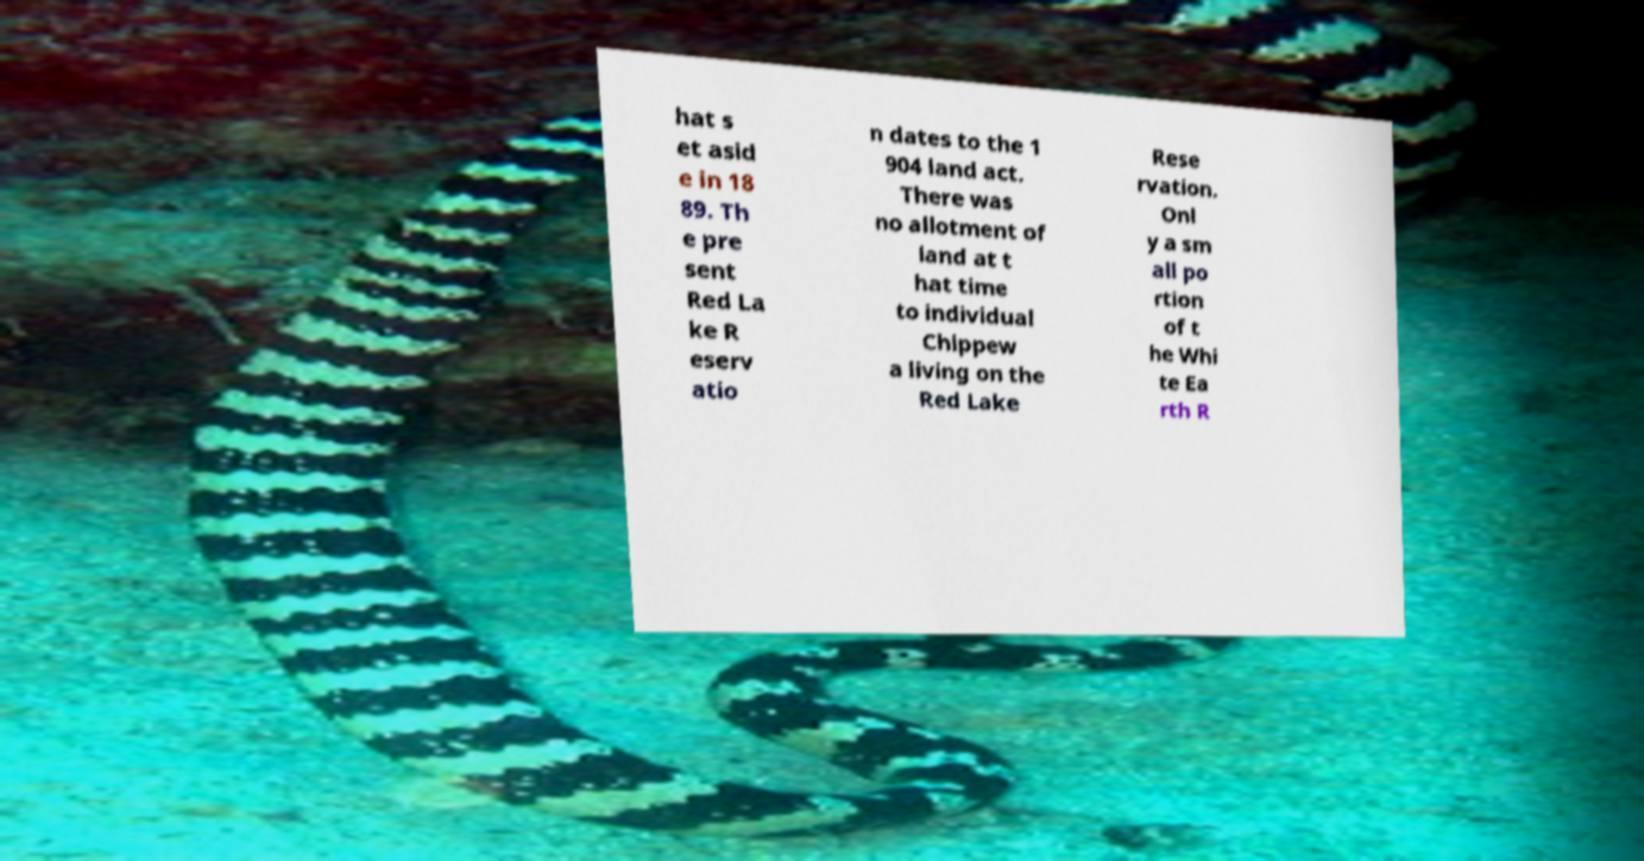For documentation purposes, I need the text within this image transcribed. Could you provide that? hat s et asid e in 18 89. Th e pre sent Red La ke R eserv atio n dates to the 1 904 land act. There was no allotment of land at t hat time to individual Chippew a living on the Red Lake Rese rvation. Onl y a sm all po rtion of t he Whi te Ea rth R 